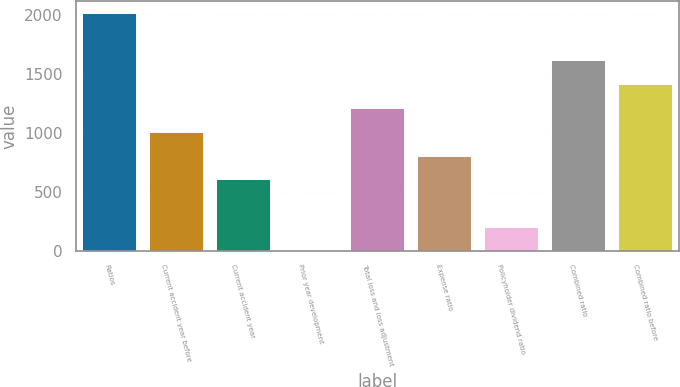Convert chart. <chart><loc_0><loc_0><loc_500><loc_500><bar_chart><fcel>Ratios<fcel>Current accident year before<fcel>Current accident year<fcel>Prior year development<fcel>Total loss and loss adjustment<fcel>Expense ratio<fcel>Policyholder dividend ratio<fcel>Combined ratio<fcel>Combined ratio before<nl><fcel>2014<fcel>1007.1<fcel>604.34<fcel>0.2<fcel>1208.48<fcel>805.72<fcel>201.58<fcel>1611.24<fcel>1409.86<nl></chart> 